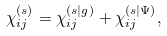<formula> <loc_0><loc_0><loc_500><loc_500>\chi ^ { ( s ) } _ { i j } = \chi ^ { ( s | g ) } _ { i j } + \chi ^ { ( s | \Psi ) } _ { i j } ,</formula> 